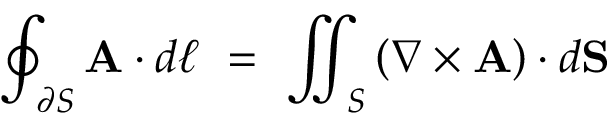Convert formula to latex. <formula><loc_0><loc_0><loc_500><loc_500>\oint _ { \partial S } A \cdot d { \ell } \ = \ \iint _ { S } \left ( \nabla \times A \right ) \cdot d S</formula> 